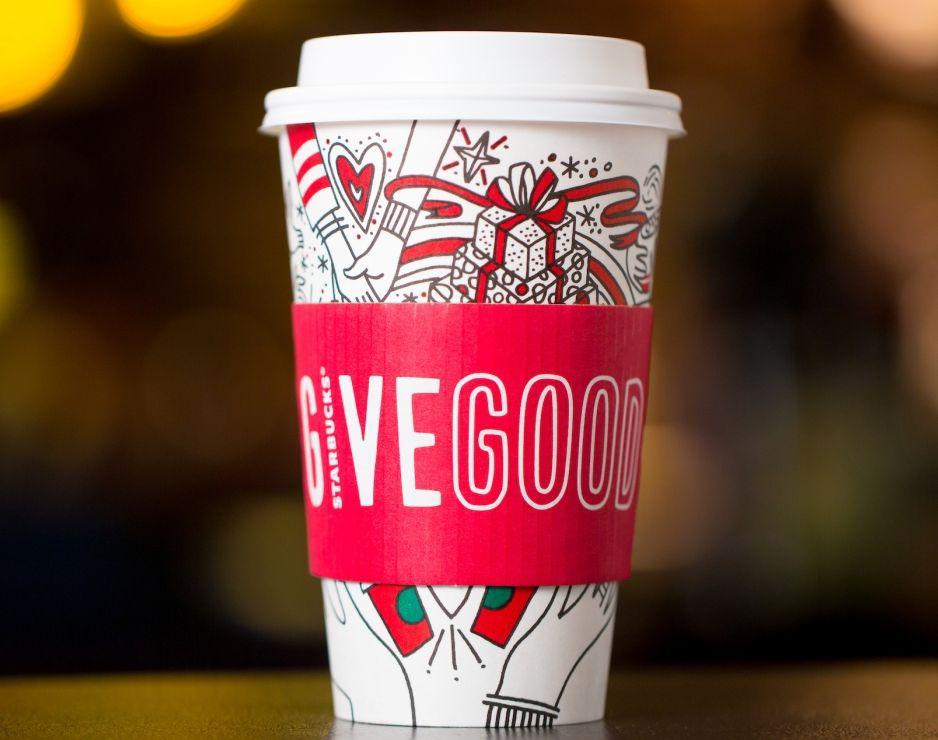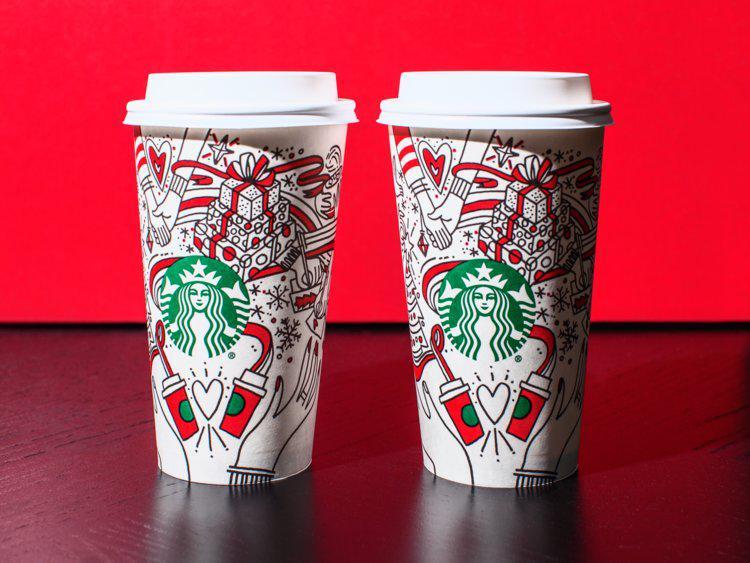The first image is the image on the left, the second image is the image on the right. Given the left and right images, does the statement "At least one image includes a white cup with a lid on it and an illustration of holding hands on its front." hold true? Answer yes or no. Yes. 